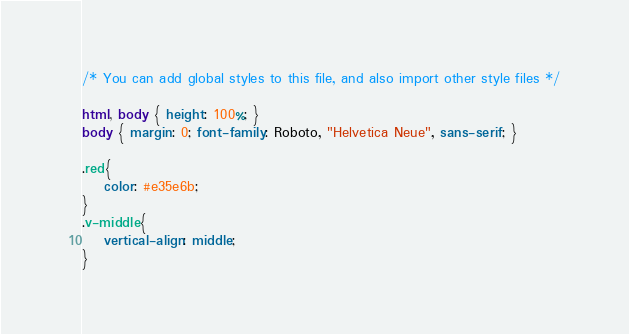Convert code to text. <code><loc_0><loc_0><loc_500><loc_500><_CSS_>/* You can add global styles to this file, and also import other style files */

html, body { height: 100%; }
body { margin: 0; font-family: Roboto, "Helvetica Neue", sans-serif; }

.red{
    color: #e35e6b;
}
.v-middle{
    vertical-align: middle;
}</code> 